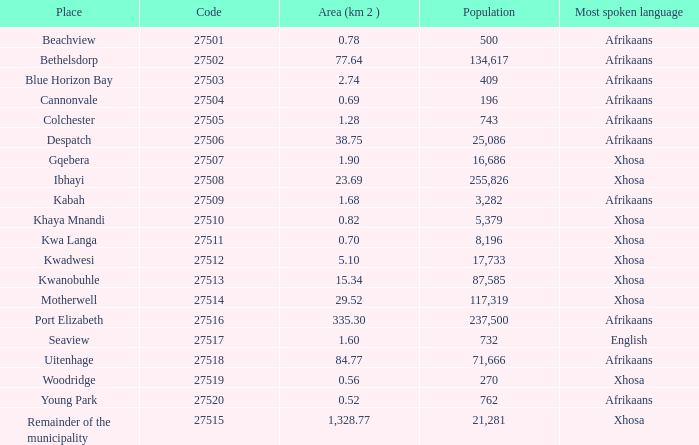What is the minimum code number for the rest of the municipality with an area over 1 27515.0. 